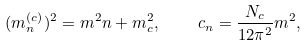Convert formula to latex. <formula><loc_0><loc_0><loc_500><loc_500>( m _ { n } ^ { ( c ) } ) ^ { 2 } = m ^ { 2 } n + m _ { c } ^ { 2 } , \quad c _ { n } = \frac { N _ { c } } { 1 2 \pi ^ { 2 } } m ^ { 2 } ,</formula> 